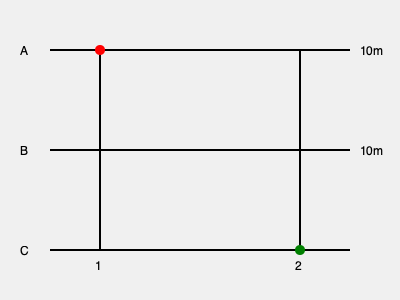In a warehouse layout, three parallel conveyor belts (A, B, and C) are connected by two perpendicular transfer belts (1 and 2). Each conveyor belt is 10 meters apart. A package starts at the red point and needs to reach the green point. What is the shortest distance the package must travel along the conveyor system? To find the shortest distance, we need to consider all possible paths and calculate their lengths:

1. Path 1: A → 2 → C
   Distance = 20m (along A) + 20m (along 2) = 40m

2. Path 2: A → 1 → C
   Distance = 0m (along A) + 20m (along 1) + 20m (along C) = 40m

3. Path 3: A → 1 → B → 2 → C
   Distance = 0m (along A) + 10m (along 1) + 10m (along B) + 10m (along 2) = 30m

4. Path 4: A → B → 2 → C
   Distance = 10m (along A) + 10m (along B) + 10m (along 2) = 30m

Paths 3 and 4 are the shortest, both measuring 30 meters. The package can take either of these routes to travel the minimum distance.

The shortest distance is therefore 30 meters.
Answer: 30 meters 